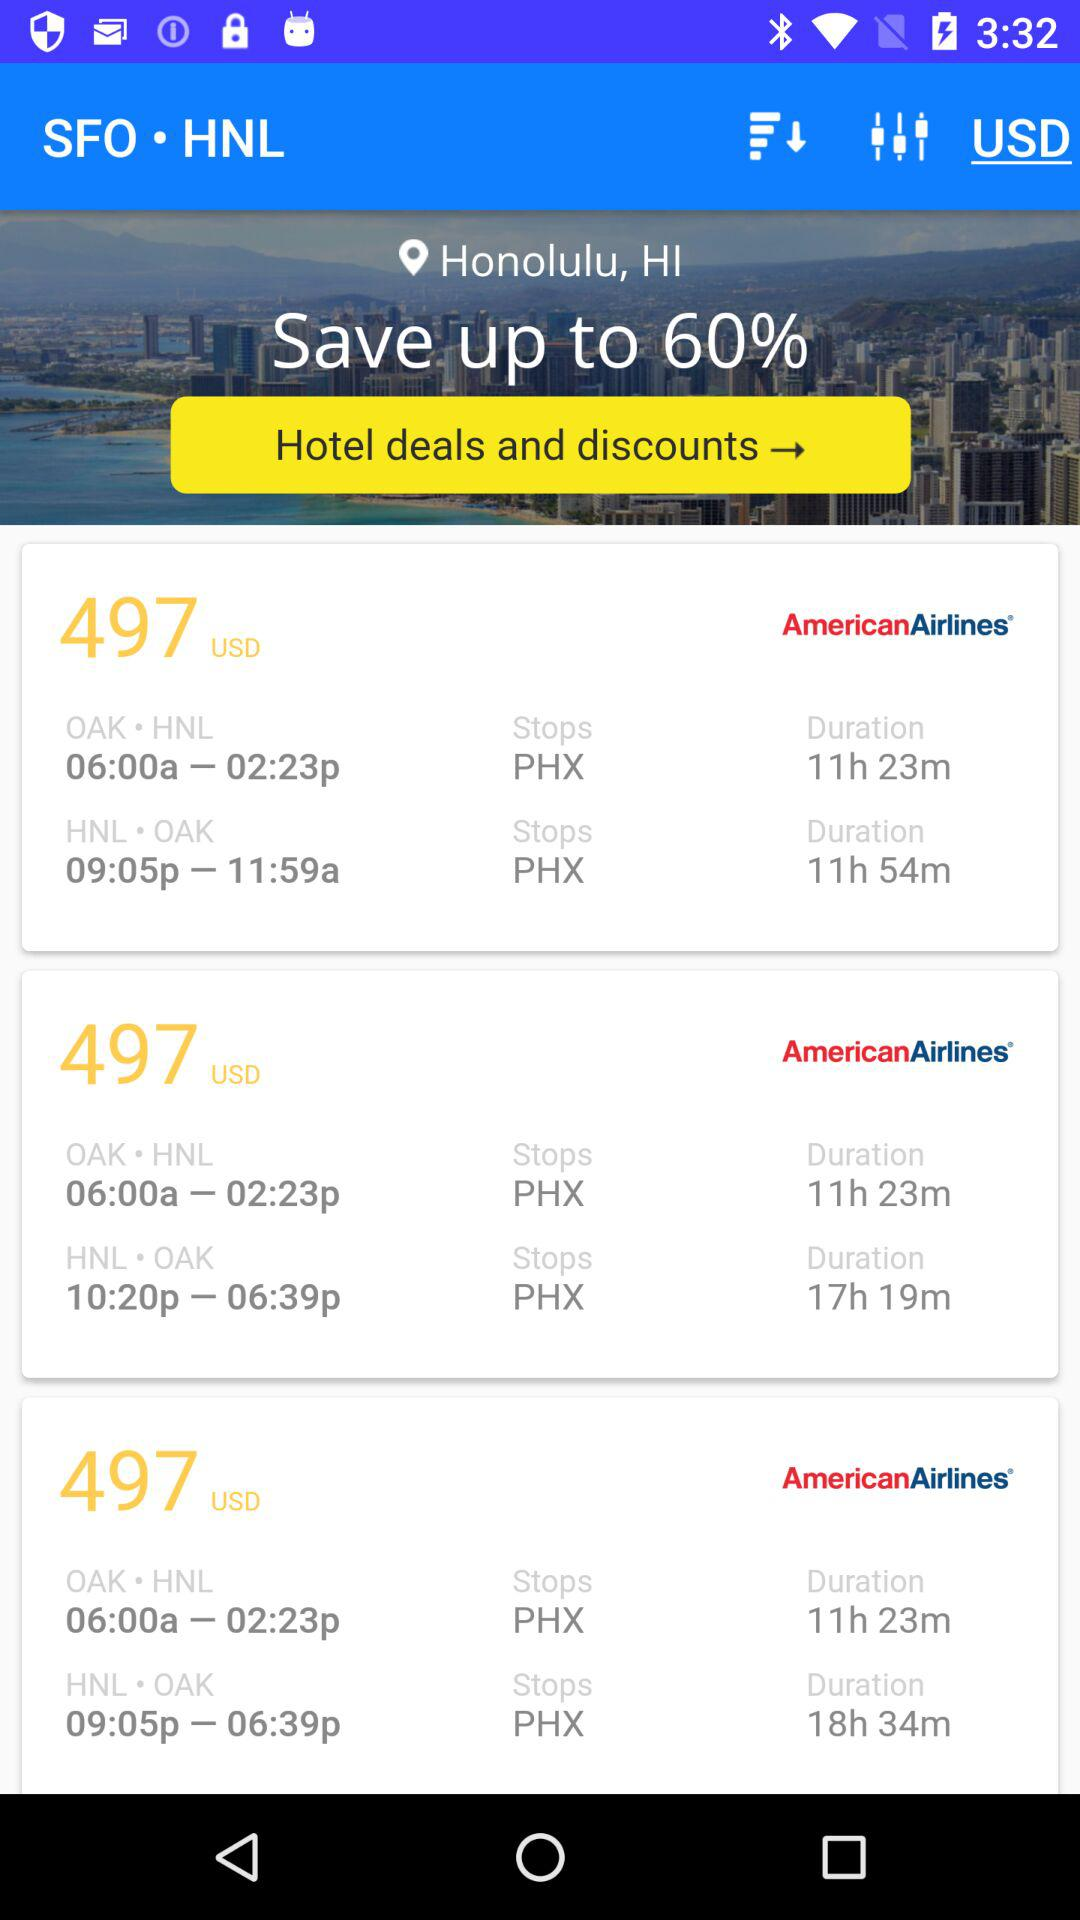What's the stop name for the OAK to HNL trip? The stop name for the OAK to HNL trip is PHX. 